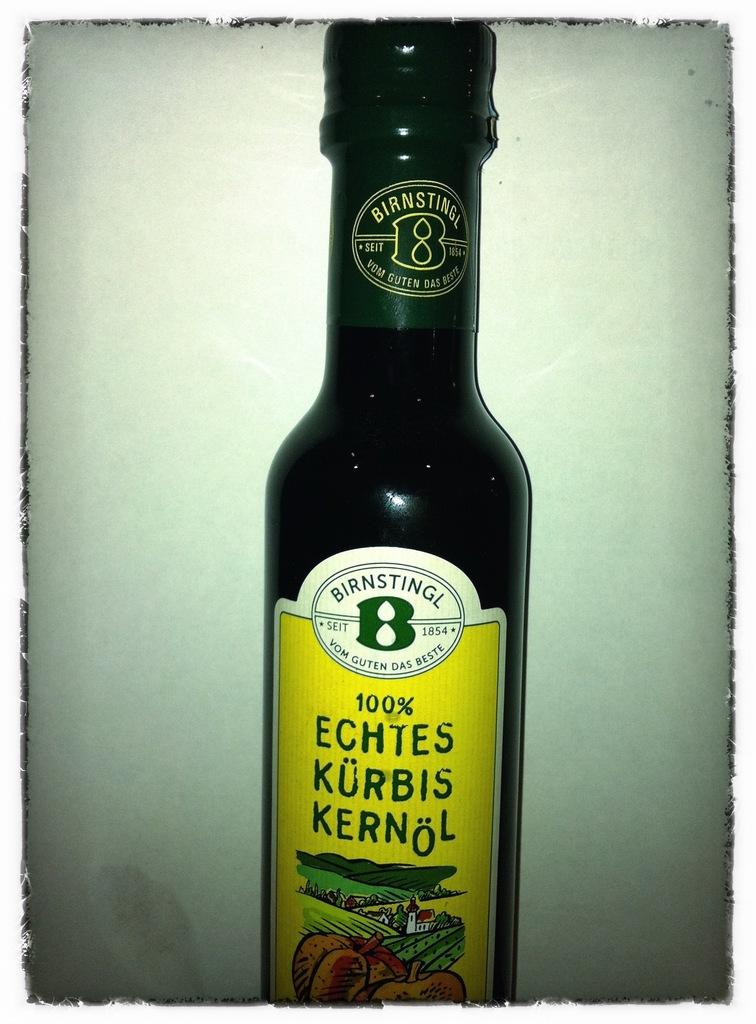<image>
Describe the image concisely. A bottle of Birnstingl Echtes Kurbis Kernol against a white backdrop. 